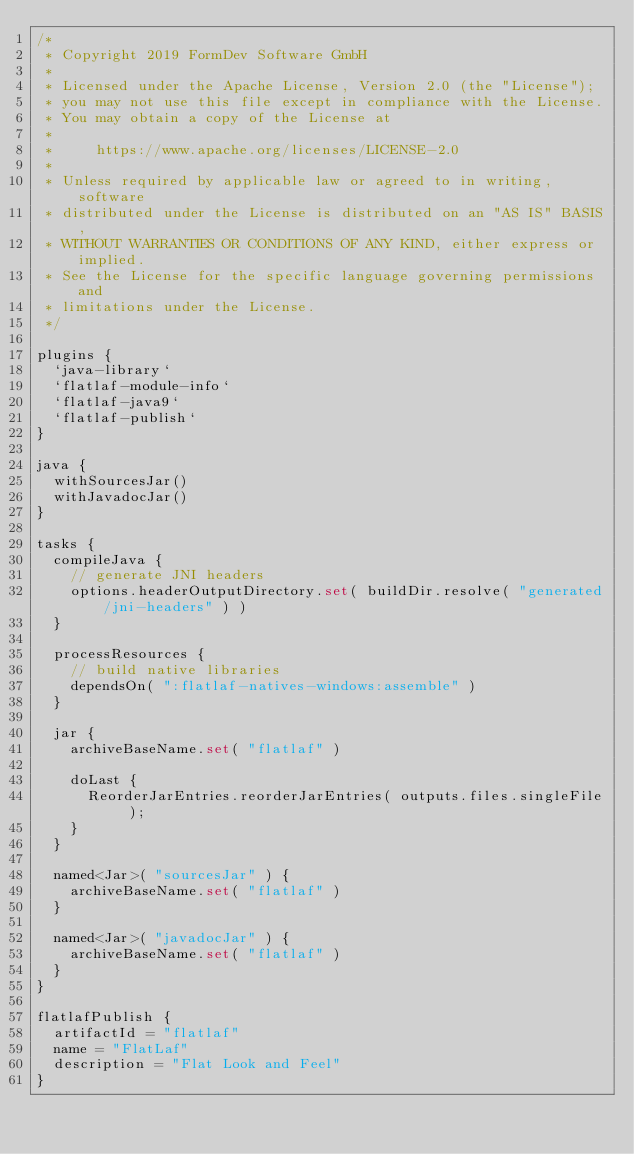<code> <loc_0><loc_0><loc_500><loc_500><_Kotlin_>/*
 * Copyright 2019 FormDev Software GmbH
 *
 * Licensed under the Apache License, Version 2.0 (the "License");
 * you may not use this file except in compliance with the License.
 * You may obtain a copy of the License at
 *
 *     https://www.apache.org/licenses/LICENSE-2.0
 *
 * Unless required by applicable law or agreed to in writing, software
 * distributed under the License is distributed on an "AS IS" BASIS,
 * WITHOUT WARRANTIES OR CONDITIONS OF ANY KIND, either express or implied.
 * See the License for the specific language governing permissions and
 * limitations under the License.
 */

plugins {
	`java-library`
	`flatlaf-module-info`
	`flatlaf-java9`
	`flatlaf-publish`
}

java {
	withSourcesJar()
	withJavadocJar()
}

tasks {
	compileJava {
		// generate JNI headers
		options.headerOutputDirectory.set( buildDir.resolve( "generated/jni-headers" ) )
	}

	processResources {
		// build native libraries
		dependsOn( ":flatlaf-natives-windows:assemble" )
	}

	jar {
		archiveBaseName.set( "flatlaf" )

		doLast {
			ReorderJarEntries.reorderJarEntries( outputs.files.singleFile );
		}
	}

	named<Jar>( "sourcesJar" ) {
		archiveBaseName.set( "flatlaf" )
	}

	named<Jar>( "javadocJar" ) {
		archiveBaseName.set( "flatlaf" )
	}
}

flatlafPublish {
	artifactId = "flatlaf"
	name = "FlatLaf"
	description = "Flat Look and Feel"
}
</code> 